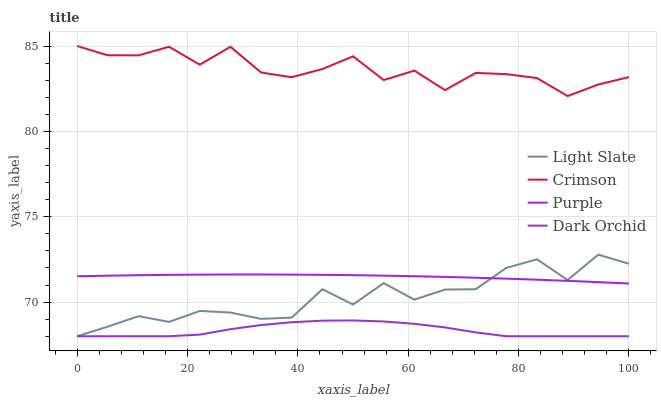Does Dark Orchid have the minimum area under the curve?
Answer yes or no. Yes. Does Crimson have the maximum area under the curve?
Answer yes or no. Yes. Does Crimson have the minimum area under the curve?
Answer yes or no. No. Does Dark Orchid have the maximum area under the curve?
Answer yes or no. No. Is Purple the smoothest?
Answer yes or no. Yes. Is Light Slate the roughest?
Answer yes or no. Yes. Is Crimson the smoothest?
Answer yes or no. No. Is Crimson the roughest?
Answer yes or no. No. Does Light Slate have the lowest value?
Answer yes or no. Yes. Does Crimson have the lowest value?
Answer yes or no. No. Does Crimson have the highest value?
Answer yes or no. Yes. Does Dark Orchid have the highest value?
Answer yes or no. No. Is Dark Orchid less than Purple?
Answer yes or no. Yes. Is Crimson greater than Purple?
Answer yes or no. Yes. Does Light Slate intersect Purple?
Answer yes or no. Yes. Is Light Slate less than Purple?
Answer yes or no. No. Is Light Slate greater than Purple?
Answer yes or no. No. Does Dark Orchid intersect Purple?
Answer yes or no. No. 